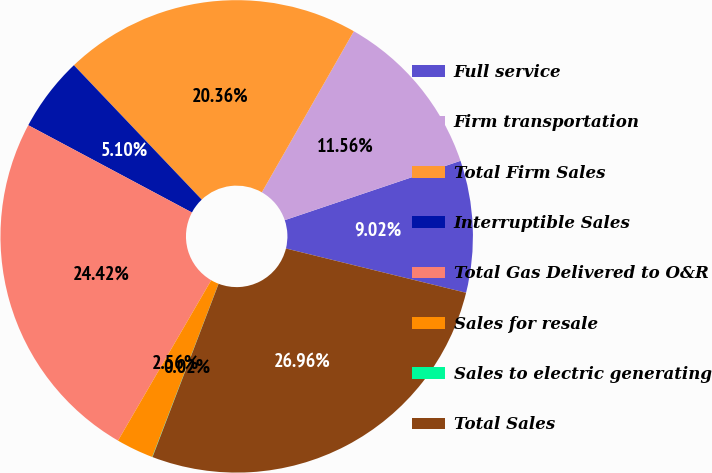<chart> <loc_0><loc_0><loc_500><loc_500><pie_chart><fcel>Full service<fcel>Firm transportation<fcel>Total Firm Sales<fcel>Interruptible Sales<fcel>Total Gas Delivered to O&R<fcel>Sales for resale<fcel>Sales to electric generating<fcel>Total Sales<nl><fcel>9.02%<fcel>11.56%<fcel>20.36%<fcel>5.1%<fcel>24.42%<fcel>2.56%<fcel>0.02%<fcel>26.96%<nl></chart> 